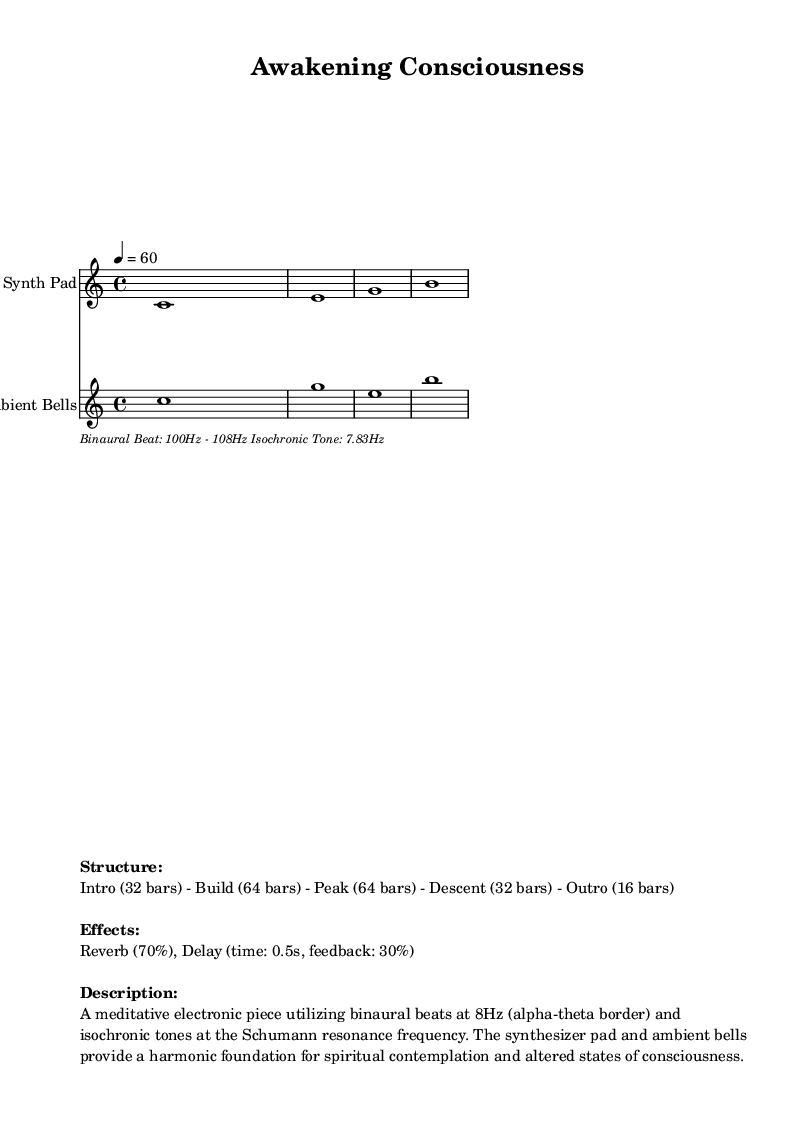What is the key signature of this music? The key signature is C major, which is indicated by the absence of any sharps or flats in the music.
Answer: C major What is the time signature of this composition? The time signature is 4/4, which means there are four beats in each measure and the quarter note receives one beat.
Answer: 4/4 What is the tempo of the piece? The tempo is set at 60 beats per minute, indicated by the tempo marking in the score.
Answer: 60 How many bars are in the Intro section? The Intro section consists of 32 bars, as specified in the structural breakdown of the piece.
Answer: 32 bars What frequency range is specified for the binaural beats? The binaural beat frequency range is from 100Hz to 108Hz, as noted in the lyrics section of the score.
Answer: 100Hz - 108Hz What effect is applied at 70%? The effect applied at 70% is Reverb, which adds depth and space to the sound.
Answer: Reverb How many measures are there in the entire piece? The total number of measures can be calculated by summing the measures of each section: Intro (32) + Build (64) + Peak (64) + Descent (32) + Outro (16) = 208 measures.
Answer: 208 measures 